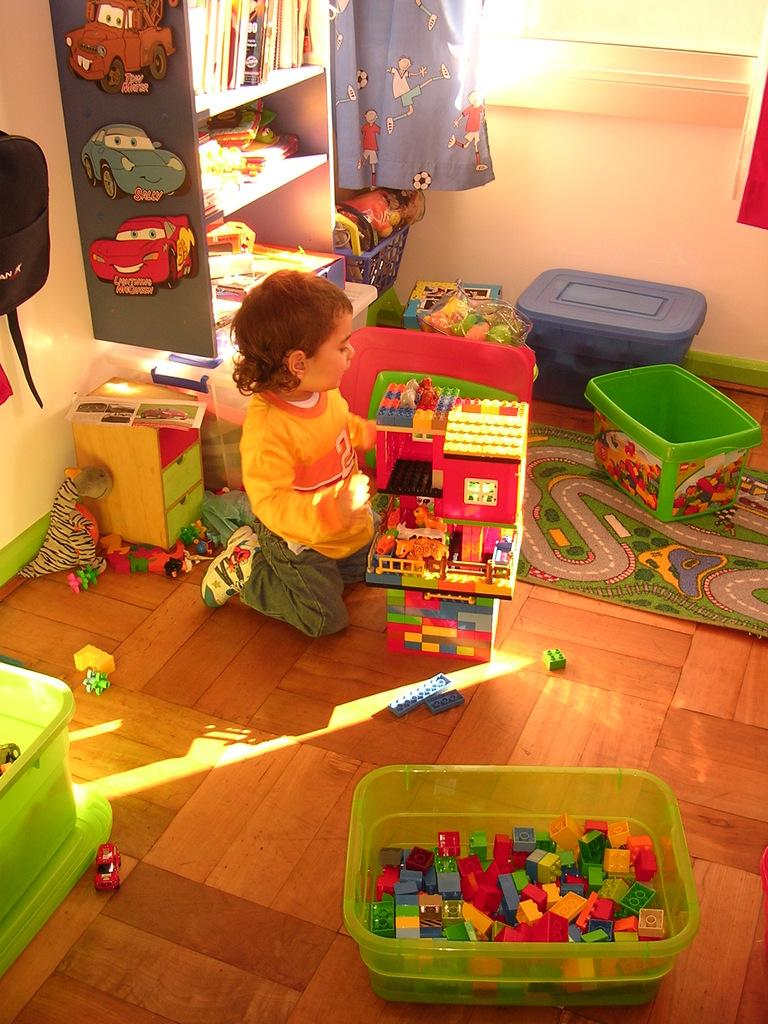What is the main subject of the image? There is a baby in the image. What is the baby wearing? The baby is wearing clothes and shoes. What other items can be seen in the image? There are toys, plastic containers, curtains, books on shelves, a wall, and a window in the image. How many beds are visible in the image? There are no beds present in the image. What type of net is used to catch the baby in the image? There is no net present in the image, and the baby is not in a situation where they would need to be caught. 